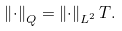<formula> <loc_0><loc_0><loc_500><loc_500>\left \| \cdot \right \| _ { Q } = \left \| \cdot \right \| _ { L ^ { 2 } } T .</formula> 